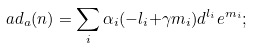<formula> <loc_0><loc_0><loc_500><loc_500>a d _ { a } ( n ) = \sum _ { i } \alpha _ { i } ( - l _ { i } { + } \gamma m _ { i } ) d ^ { l _ { i } } e ^ { m _ { i } } ;</formula> 